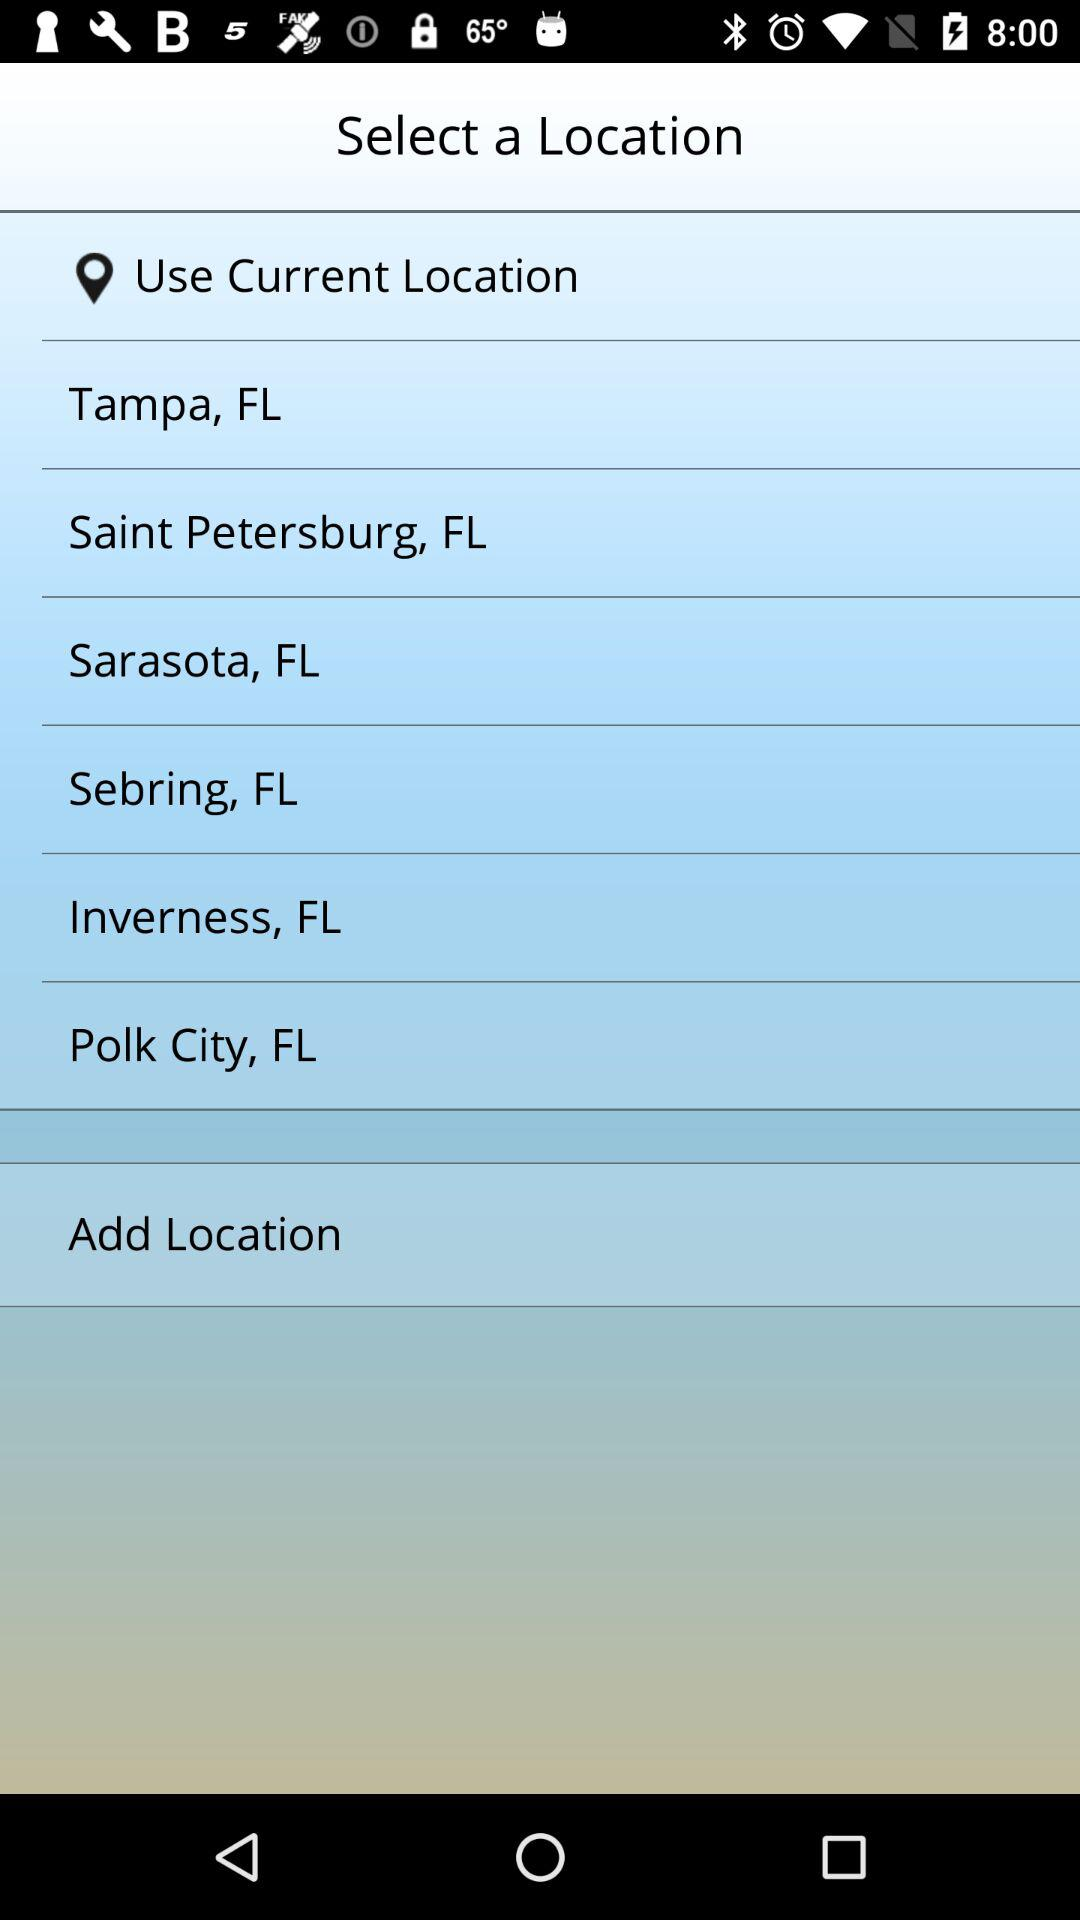Which location is chosen?
When the provided information is insufficient, respond with <no answer>. <no answer> 